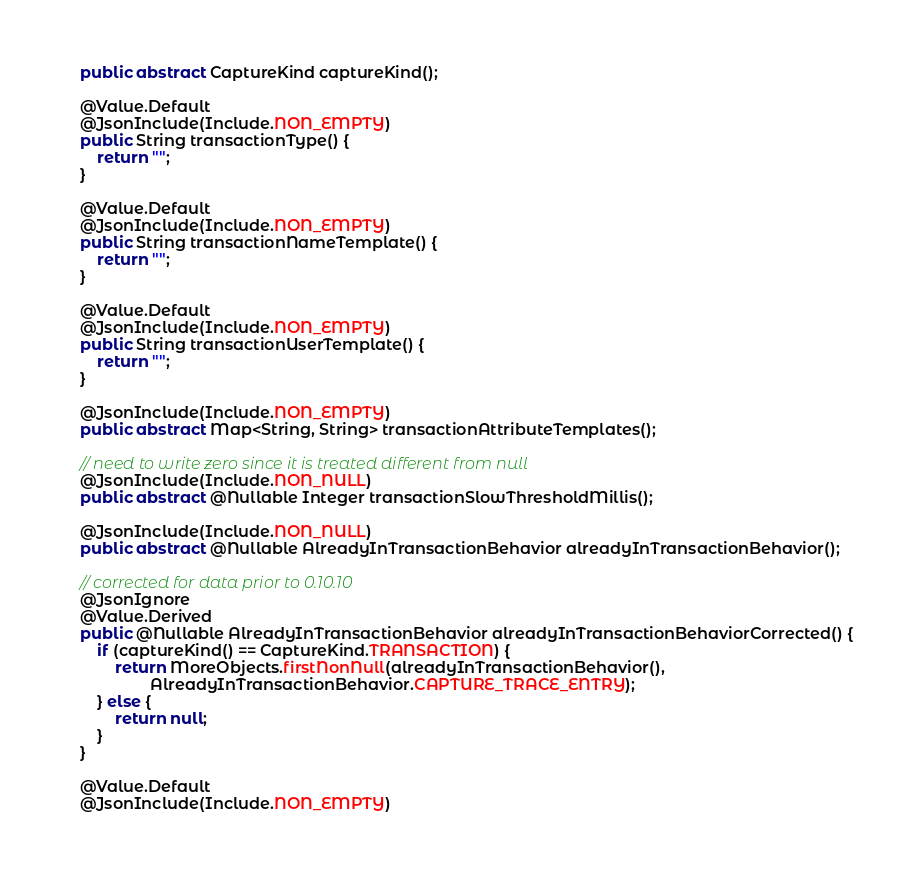Convert code to text. <code><loc_0><loc_0><loc_500><loc_500><_Java_>    public abstract CaptureKind captureKind();

    @Value.Default
    @JsonInclude(Include.NON_EMPTY)
    public String transactionType() {
        return "";
    }

    @Value.Default
    @JsonInclude(Include.NON_EMPTY)
    public String transactionNameTemplate() {
        return "";
    }

    @Value.Default
    @JsonInclude(Include.NON_EMPTY)
    public String transactionUserTemplate() {
        return "";
    }

    @JsonInclude(Include.NON_EMPTY)
    public abstract Map<String, String> transactionAttributeTemplates();

    // need to write zero since it is treated different from null
    @JsonInclude(Include.NON_NULL)
    public abstract @Nullable Integer transactionSlowThresholdMillis();

    @JsonInclude(Include.NON_NULL)
    public abstract @Nullable AlreadyInTransactionBehavior alreadyInTransactionBehavior();

    // corrected for data prior to 0.10.10
    @JsonIgnore
    @Value.Derived
    public @Nullable AlreadyInTransactionBehavior alreadyInTransactionBehaviorCorrected() {
        if (captureKind() == CaptureKind.TRANSACTION) {
            return MoreObjects.firstNonNull(alreadyInTransactionBehavior(),
                    AlreadyInTransactionBehavior.CAPTURE_TRACE_ENTRY);
        } else {
            return null;
        }
    }

    @Value.Default
    @JsonInclude(Include.NON_EMPTY)</code> 